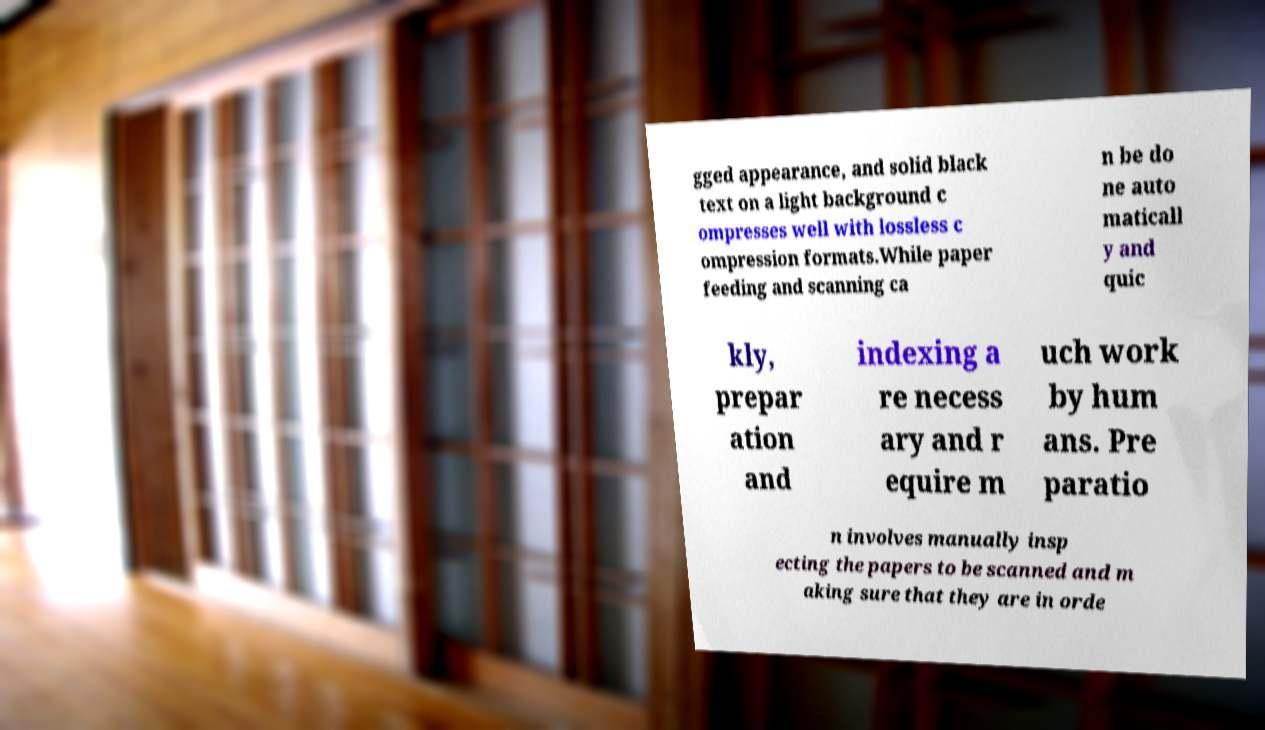Please read and relay the text visible in this image. What does it say? gged appearance, and solid black text on a light background c ompresses well with lossless c ompression formats.While paper feeding and scanning ca n be do ne auto maticall y and quic kly, prepar ation and indexing a re necess ary and r equire m uch work by hum ans. Pre paratio n involves manually insp ecting the papers to be scanned and m aking sure that they are in orde 